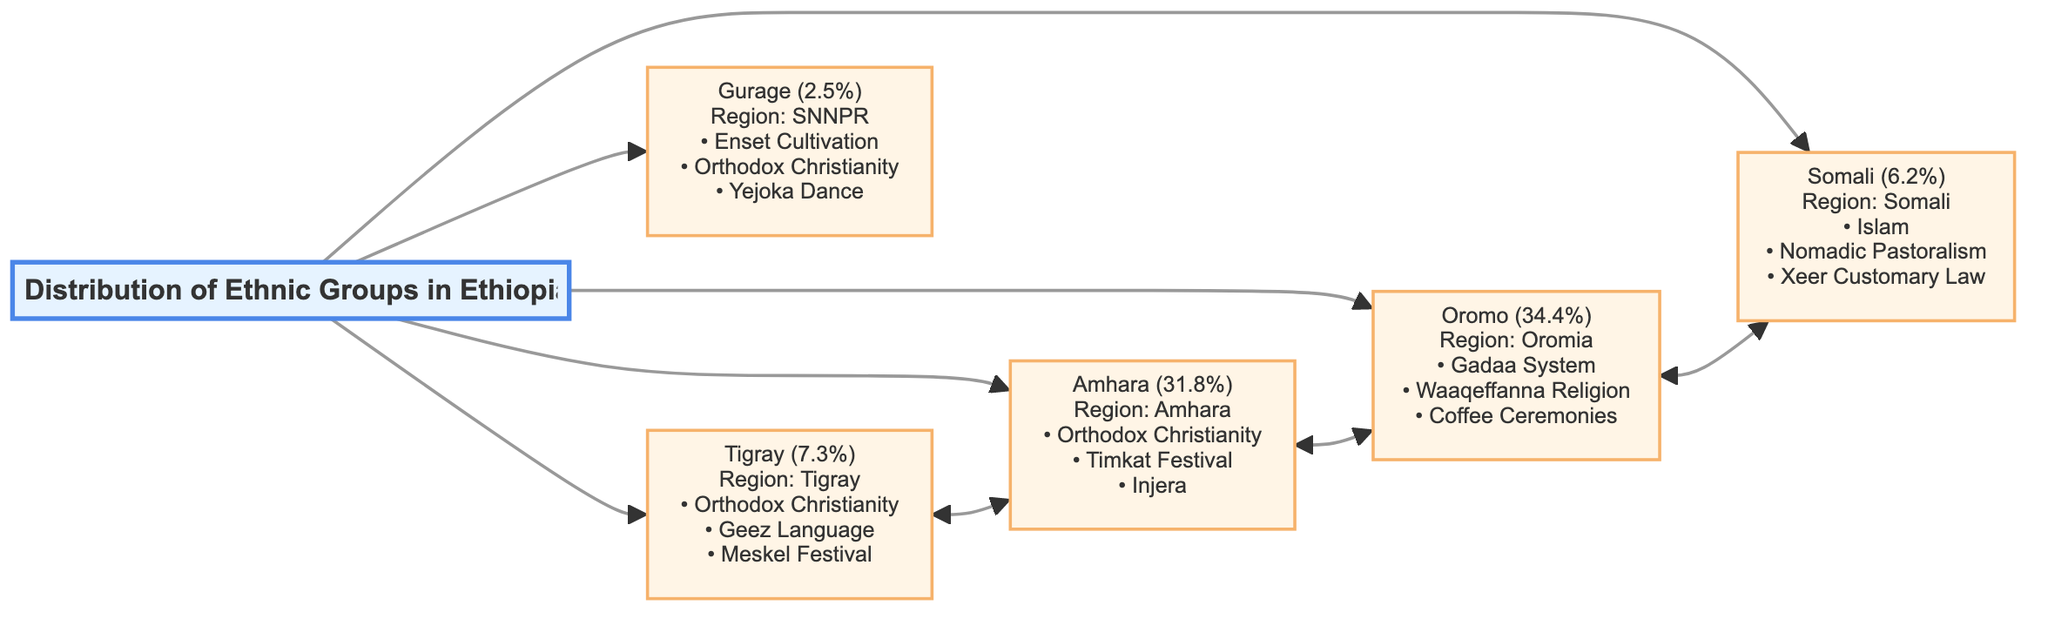What percentage of the population do the Oromo represent? The diagram states that the Oromo ethnic group constitutes 34.4% of the population in Ethiopia, which is indicated clearly next to the Oromo node.
Answer: 34.4% How many ethnic groups are represented in the diagram? The diagram features five distinct ethnic groups: Amhara, Oromo, Tigray, Somali, and Gurage, which can be counted from the nodes displayed.
Answer: 5 Which ethnic group practices the Gadaa System? Looking at the Oromo node, it is listed that the Oromo ethnic group is known for practicing the Gadaa System, among other cultural practices, as specified in the diagram.
Answer: Oromo What is a key cultural practice of the Amhara? The diagram mentions that the Amhara's key cultural practices include Orthodox Christianity, Timkat Festival, and Injera, among which Timkat Festival is one of the recognized practices.
Answer: Timkat Festival Which ethnic group is associated with the Nomadic Pastoralism practice? The Somali node indicates that their key cultural practice includes Nomadic Pastoralism, making it clear that this practice is linked to the Somali ethnic group.
Answer: Somali How many key cultural practices are listed for the Tigray? The Tigray node lists three key cultural practices: Orthodox Christianity, Geez Language, and Meskel Festival. When counted, there are three distinct practices mentioned.
Answer: 3 Which two ethnic groups are directly connected in the diagram? Observing the connections in the diagram, the Oromo and Somali ethnic groups are directly linked, indicating a relationship between them.
Answer: Oromo and Somali What notable festival is celebrated by the Tigray ethnic group? The diagram specifies that the Tigray ethnic group celebrates the Meskel Festival, identifying a significant cultural celebration for them.
Answer: Meskel Festival What is the significance of the Enset Cultivation within the Gurage culture? The Gurage node highlights Enset Cultivation as one of their key cultural practices, pointing to its importance within the Gurage culture and way of life.
Answer: Enset Cultivation 